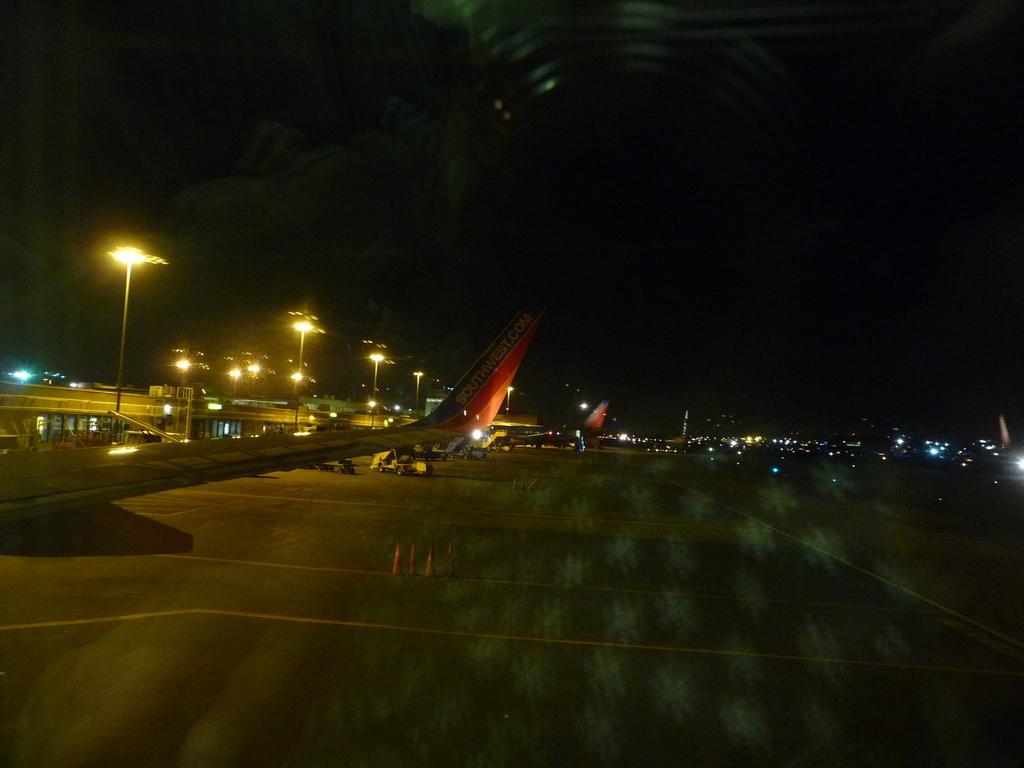Could you give a brief overview of what you see in this image? In the foreground of this image, there is road. On the left, there are airplanes, poles, lights and buildings. At the top, there is the dark sky. 